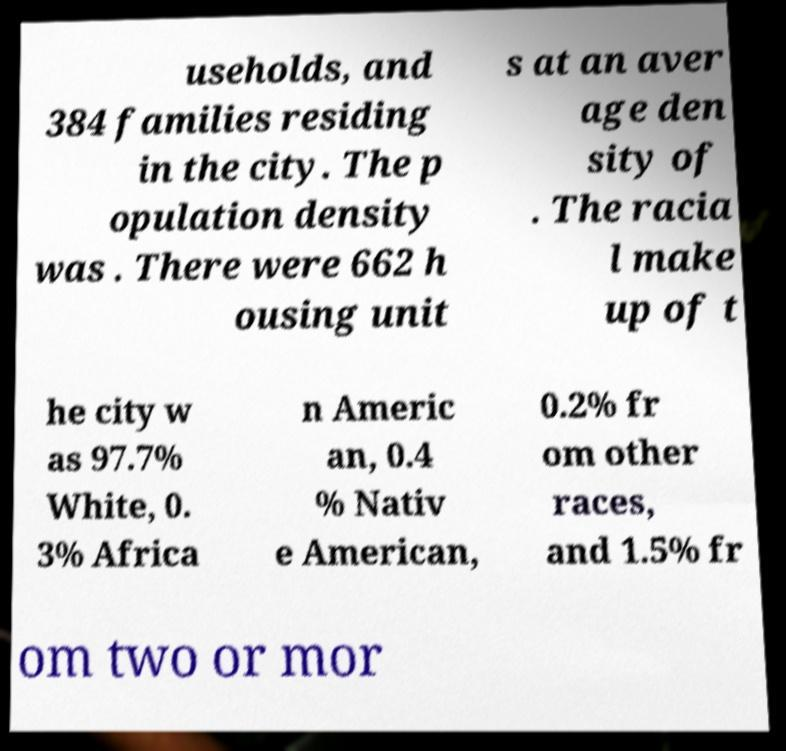Can you read and provide the text displayed in the image?This photo seems to have some interesting text. Can you extract and type it out for me? useholds, and 384 families residing in the city. The p opulation density was . There were 662 h ousing unit s at an aver age den sity of . The racia l make up of t he city w as 97.7% White, 0. 3% Africa n Americ an, 0.4 % Nativ e American, 0.2% fr om other races, and 1.5% fr om two or mor 